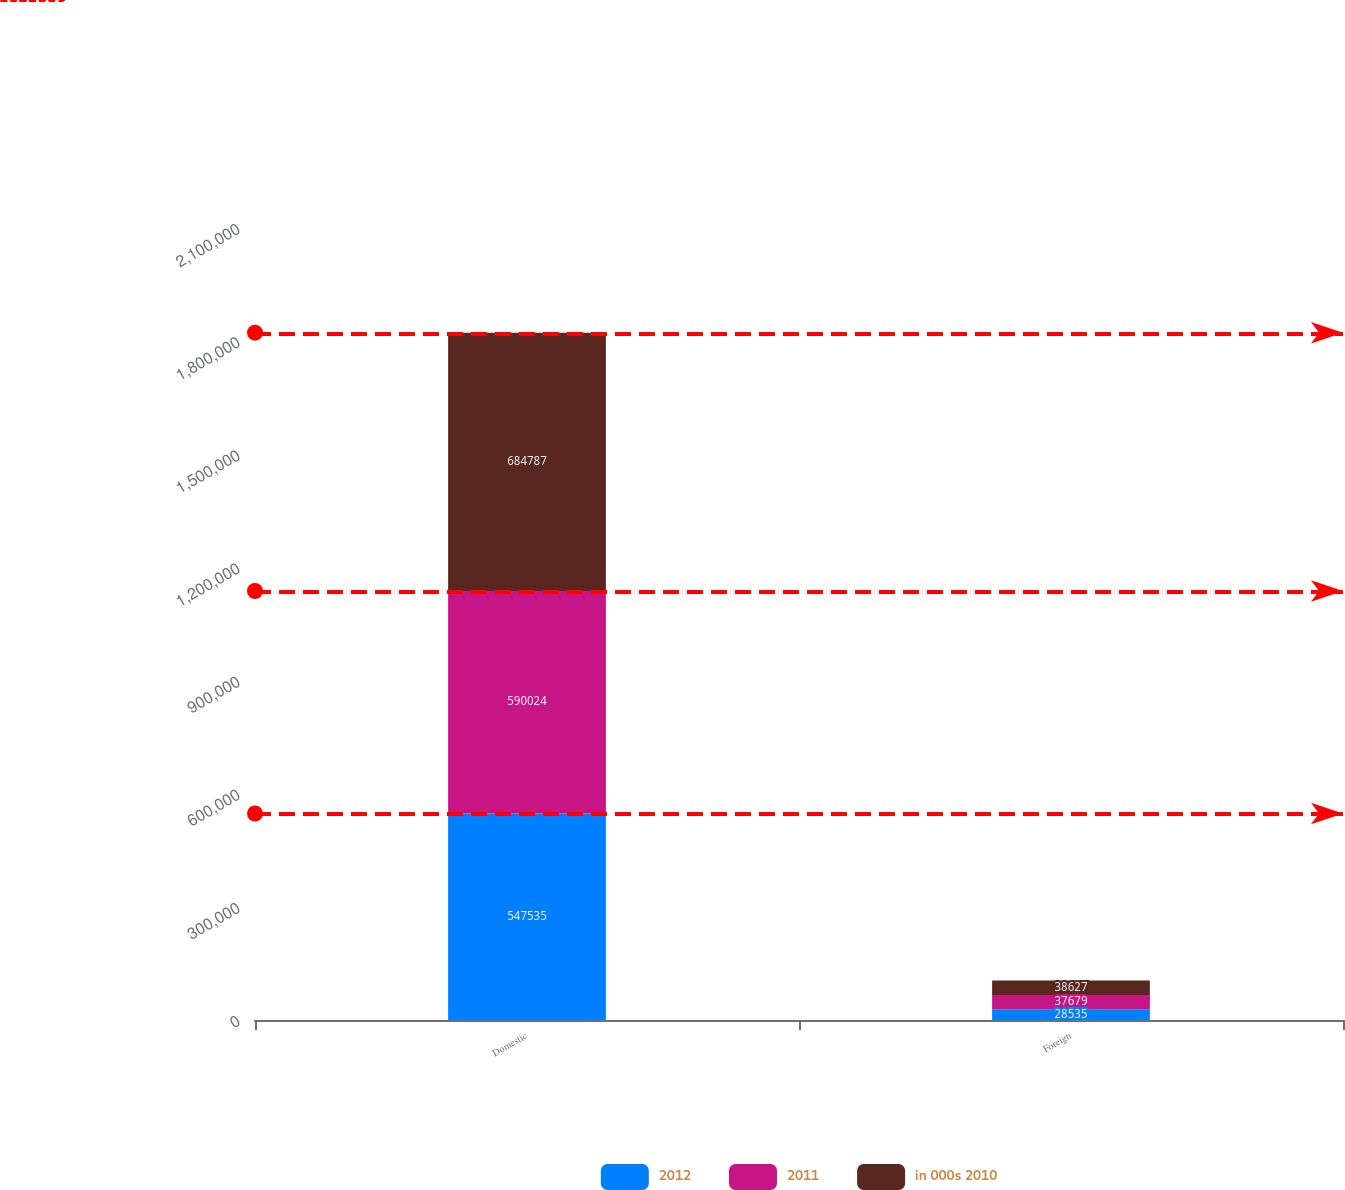Convert chart to OTSL. <chart><loc_0><loc_0><loc_500><loc_500><stacked_bar_chart><ecel><fcel>Domestic<fcel>Foreign<nl><fcel>2012<fcel>547535<fcel>28535<nl><fcel>2011<fcel>590024<fcel>37679<nl><fcel>in 000s 2010<fcel>684787<fcel>38627<nl></chart> 